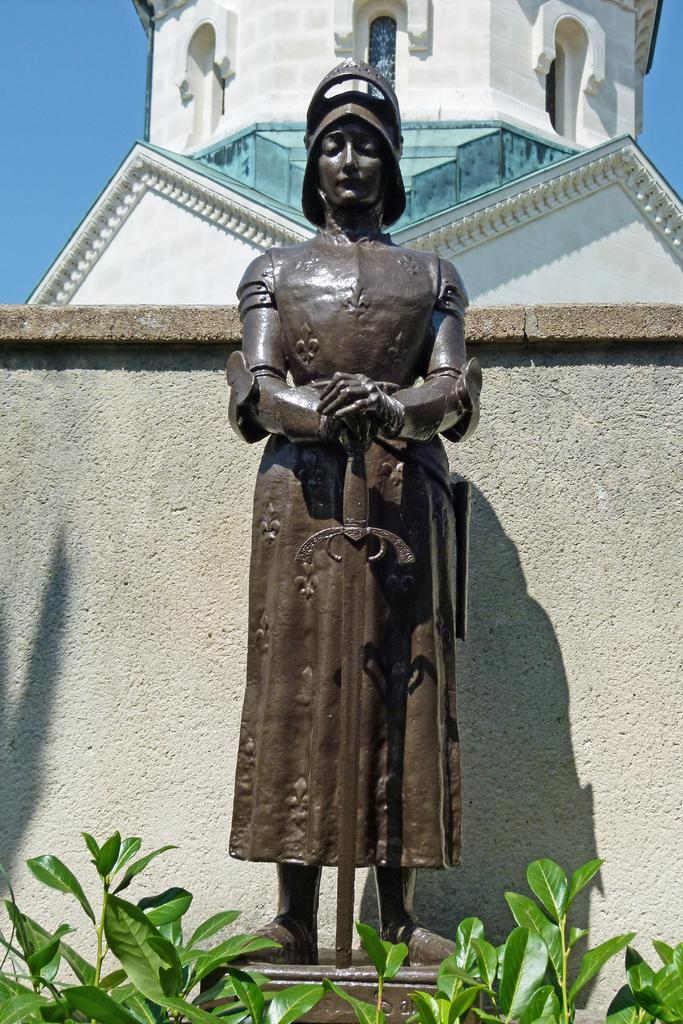What is located in the front of the image? There are plants in the front of the image. What can be seen in the center of the image? There is a statue in the center of the image. What is visible in the background of the image? There is a wall and a tower in the background of the image. What type of lace can be seen on the statue's clothing in the image? There is no lace visible on the statue's clothing in the image. What time of day is depicted in the image? The provided facts do not give any information about the time of day, so it cannot be determined from the image. 